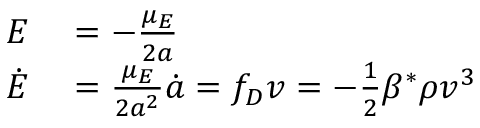Convert formula to latex. <formula><loc_0><loc_0><loc_500><loc_500>\begin{array} { r l } { E } & = - \frac { \mu _ { E } } { 2 a } } \\ { \dot { E } } & = \frac { \mu _ { E } } { 2 a ^ { 2 } } \dot { a } = f _ { D } v = - \frac { 1 } { 2 } \beta ^ { * } \rho v ^ { 3 } } \end{array}</formula> 